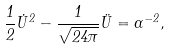<formula> <loc_0><loc_0><loc_500><loc_500>\frac { 1 } { 2 } \dot { U } ^ { 2 } - \frac { 1 } { \sqrt { 2 4 \pi } } \ddot { U } = \alpha ^ { - 2 } ,</formula> 